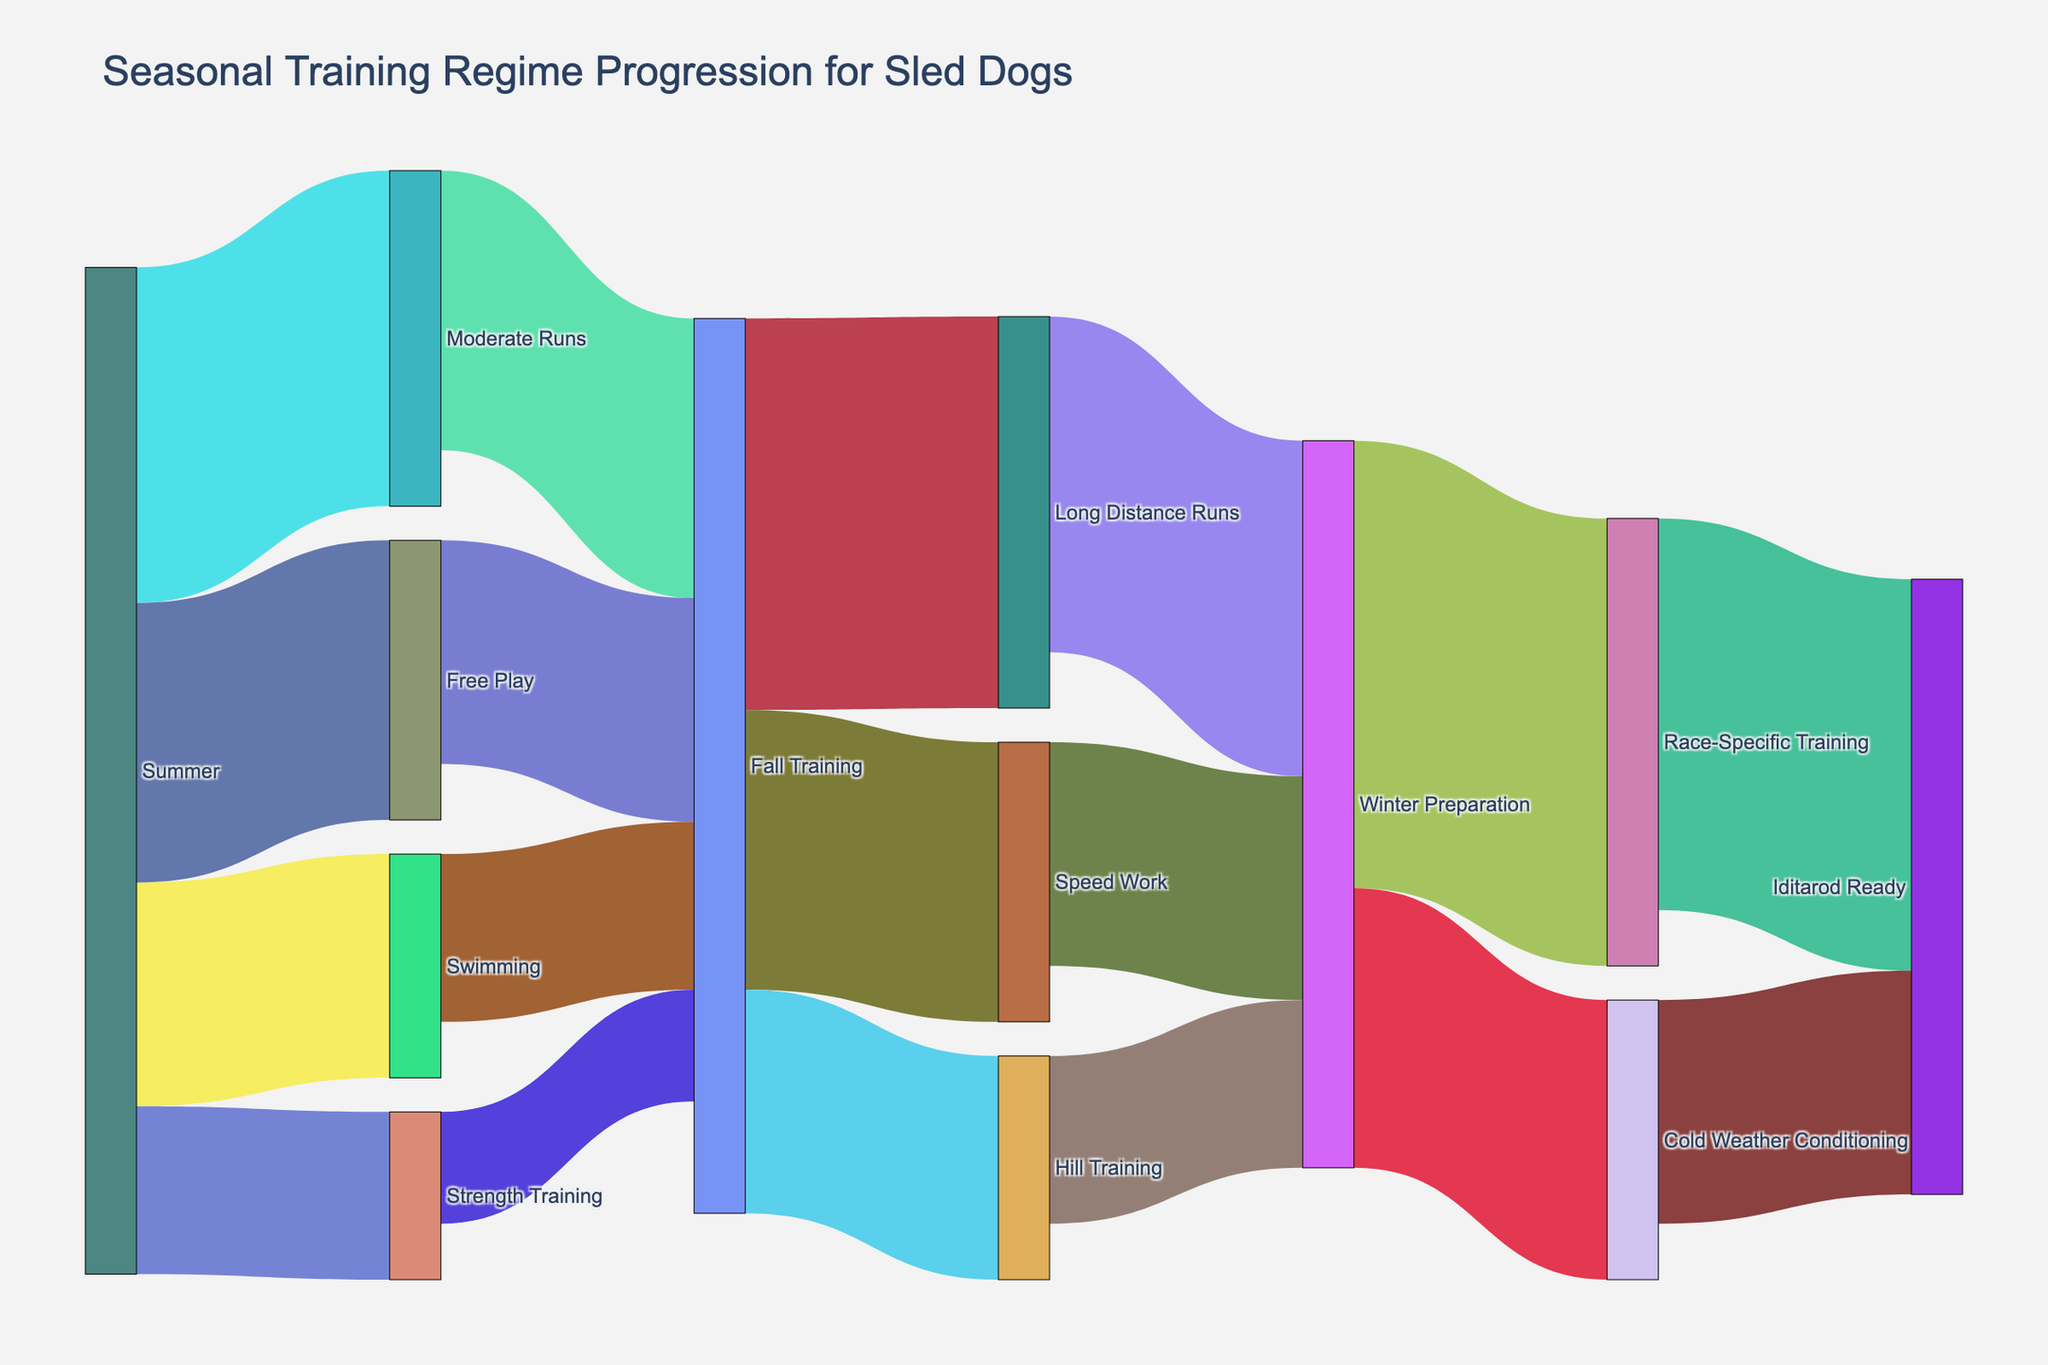what is the title of the Sankey Diagram? The title of the diagram is often positioned at the top. According to the provided code, the title is defined within the `fig.update_layout` function. The title specified is "Seasonal Training Regime Progression for Sled Dogs".
Answer: Seasonal Training Regime Progression for Sled Dogs In the Summer phase, which activity has the highest value? To determine the activity with the highest value, look at the flow values originating from "Summer". The values are 30 (Moderate Runs), 20 (Swimming), 25 (Free Play), and 15 (Strength Training). The highest value is 30, which corresponds to Moderate Runs.
Answer: Moderate Runs How many activities transition from Summer to Fall Training? Count the number of unique transitions originating from "Summer" and leading to "Fall Training". According to the data, the activities are Moderate Runs, Swimming, Free Play, and Strength Training. That's a total of 4 transitions.
Answer: 4 Which activity directly leads to the highest number of dogs reaching Winter Preparation? Look at the values associated with the transitions leading to "Winter Preparation". The activities and their values are: Long Distance Runs (30), Speed Work (20), and Hill Training (15). The highest value is 30, corresponding to Long Distance Runs.
Answer: Long Distance Runs What is the total number of dogs involved in Fall Training activities? Identify the values associated with all fall training activities: Long Distance Runs (35), Speed Work (25), Hill Training (20). Sum these values: 35 + 25 + 20 = 80 dogs.
Answer: 80 Which activity during Winter Preparation has a higher value, Race-Specific Training or Cold Weather Conditioning? Compare the values for activities originating from "Winter Preparation". Race-Specific Training has a value of 40, and Cold Weather Conditioning has a value of 25. Race-Specific Training has a higher value.
Answer: Race-Specific Training What is the combined value of dogs reaching "Iditarod Ready"? Add the values of the flows leading to "Iditarod Ready". From the data: Race-Specific Training (35) and Cold Weather Conditioning (20). Combined value is 35 + 20 = 55.
Answer: 55 From which activity in Fall Training do the most dogs transition to Winter Preparation? Examine the values of the transitions leading from "Fall Training" to "Winter Preparation". The possible activities and their values are: Long Distance Runs (30), Speed Work (20), and Hill Training (15). The highest value is 30, from Long Distance Runs.
Answer: Long Distance Runs How many dogs start their training in the Strength Training activity during Summer? Refer to the value associated with the transition from "Summer" to "Strength Training". The provided value is 15.
Answer: 15 